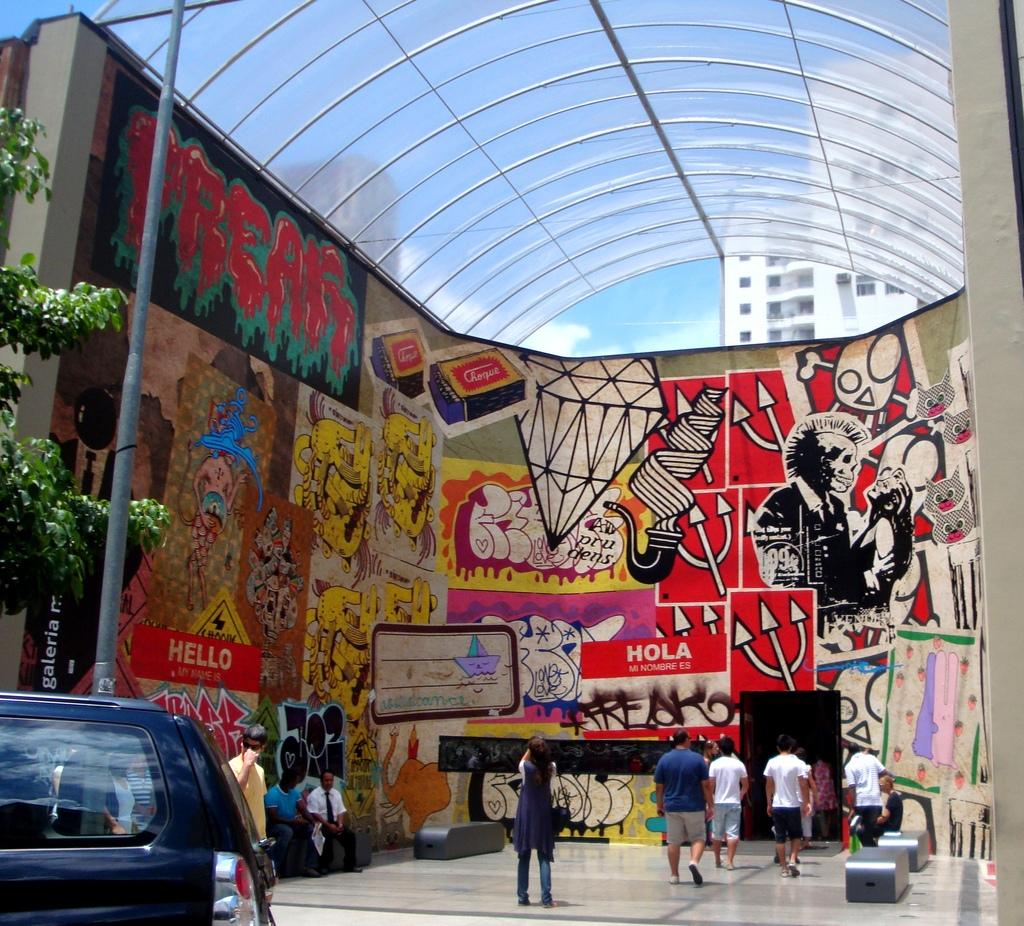<image>
Give a short and clear explanation of the subsequent image. A wall with an art piece that says Hello My Name is on it. 